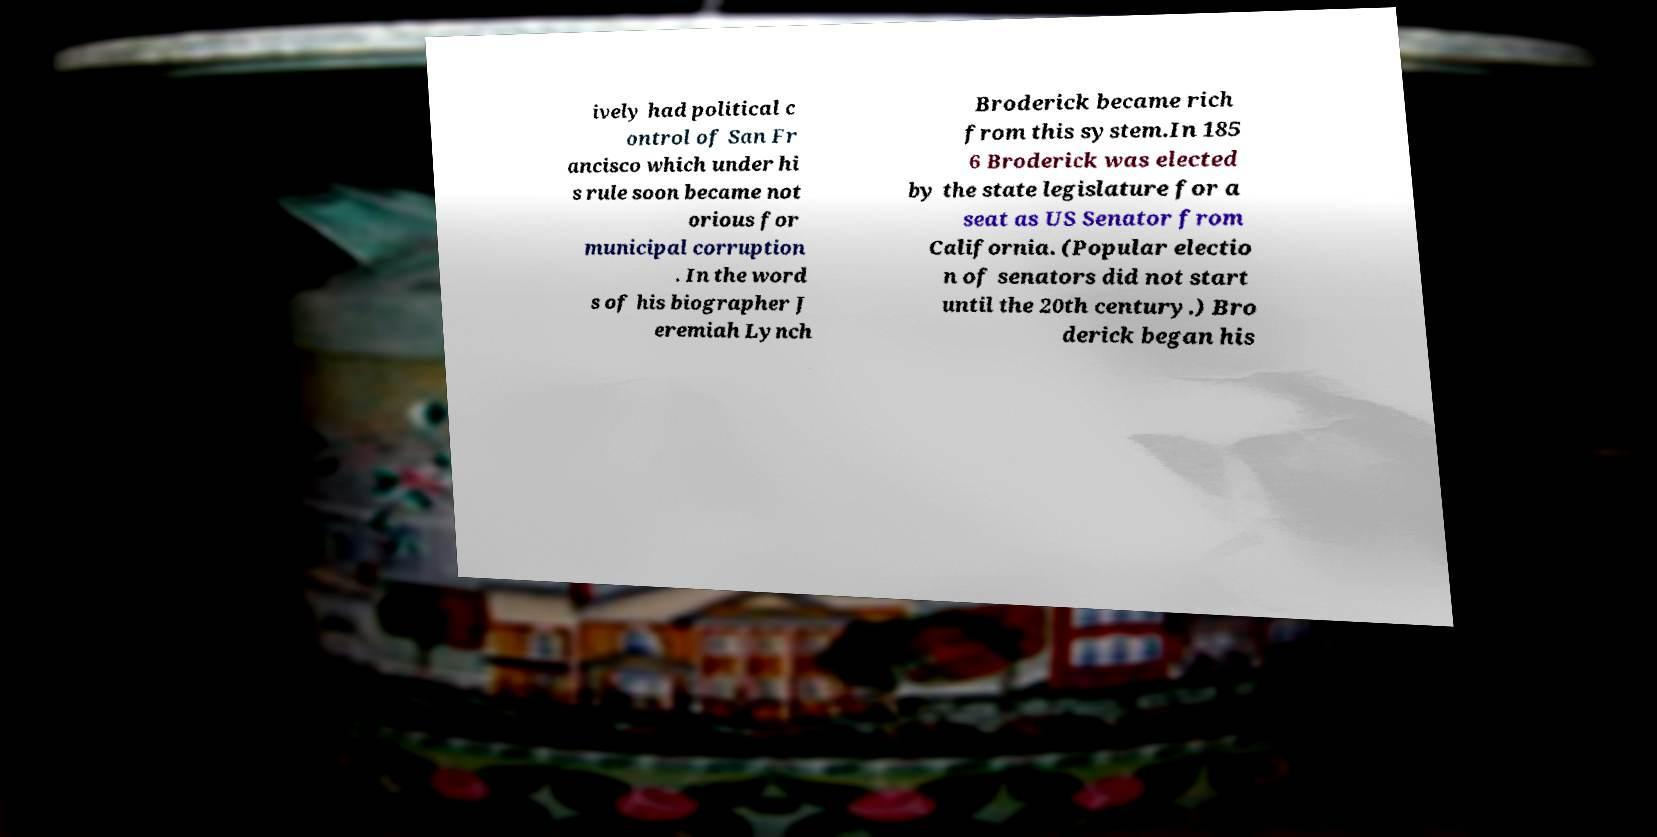What messages or text are displayed in this image? I need them in a readable, typed format. ively had political c ontrol of San Fr ancisco which under hi s rule soon became not orious for municipal corruption . In the word s of his biographer J eremiah Lynch Broderick became rich from this system.In 185 6 Broderick was elected by the state legislature for a seat as US Senator from California. (Popular electio n of senators did not start until the 20th century.) Bro derick began his 